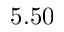Convert formula to latex. <formula><loc_0><loc_0><loc_500><loc_500>5 . 5 0</formula> 